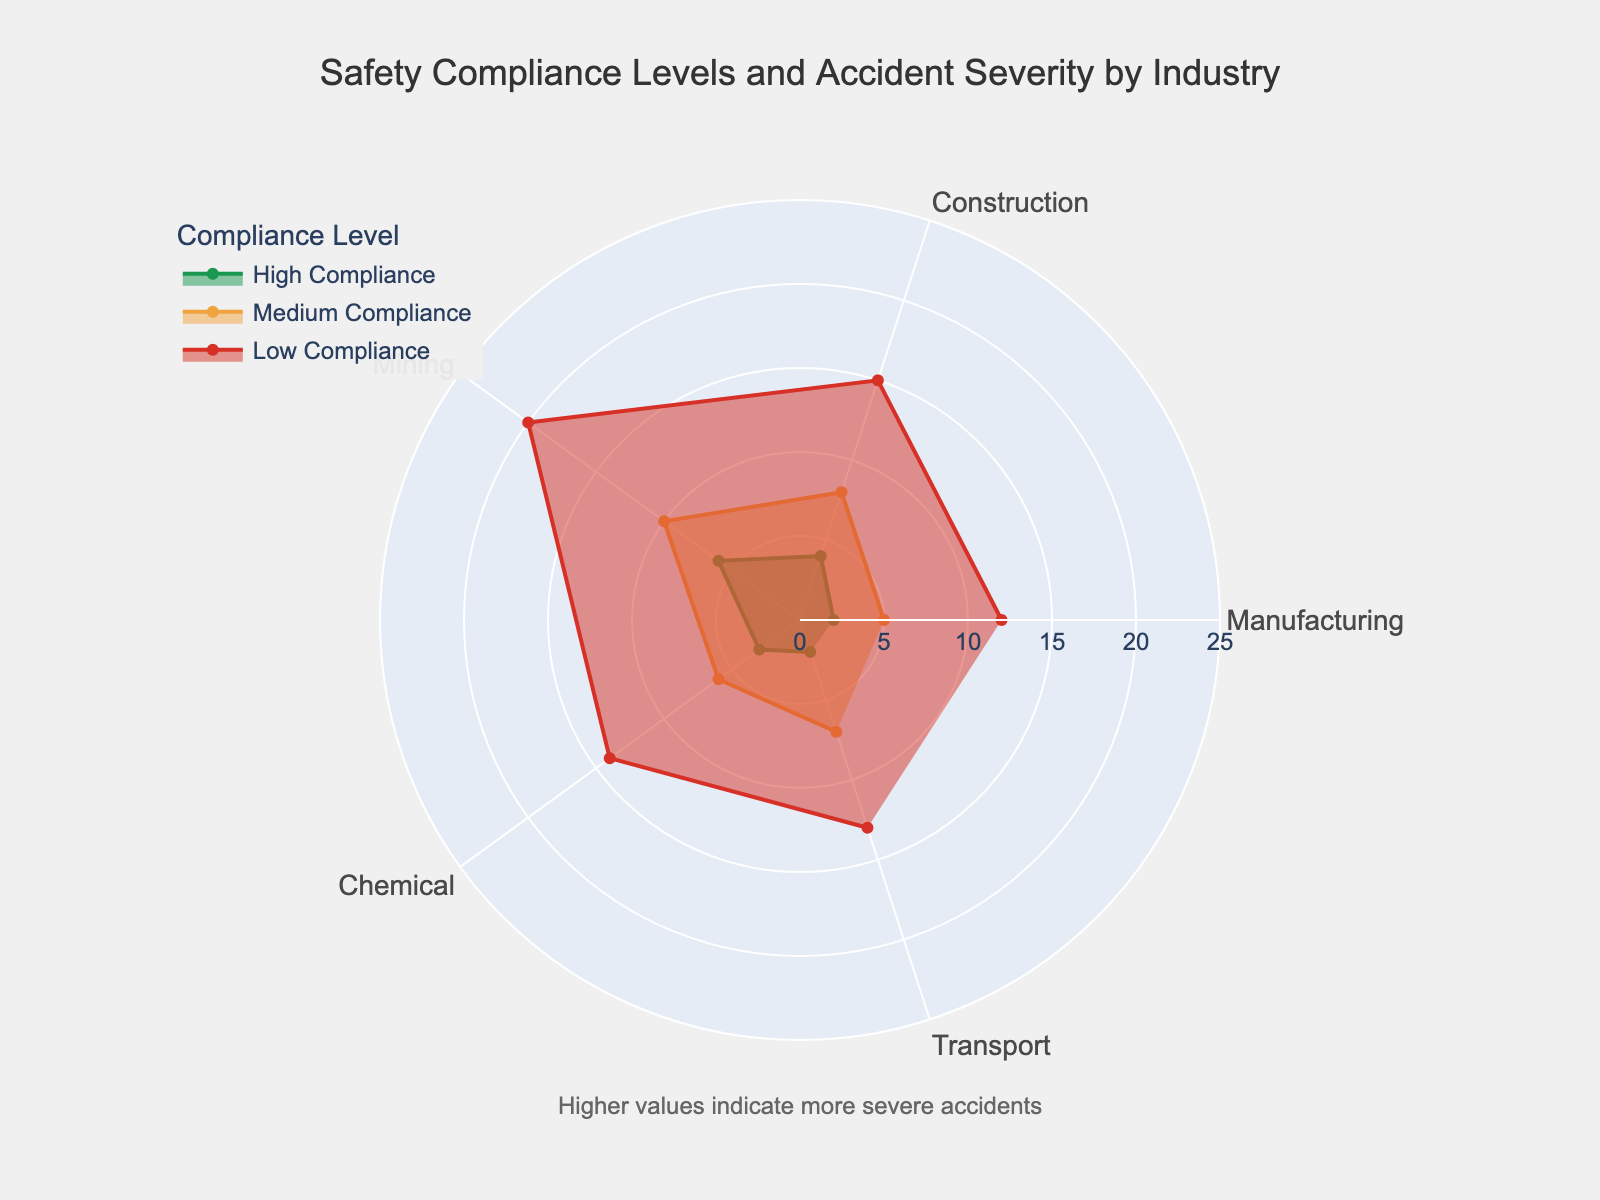What is the title of the figure? The title is usually displayed at the top of the figure. In this case, the title is "Safety Compliance Levels and Accident Severity by Industry."
Answer: Safety Compliance Levels and Accident Severity by Industry What industry has the highest accident severity level for High Compliance? To find this, look at the 'High Compliance' trace, find the highest value, and then identify the corresponding industry category. The maximum value is 6 for the Mining industry.
Answer: Mining Which compliance level shows the highest values of accident severity overall? Compare the values across the different compliance levels. The 'Low Compliance' category has higher values in all industries.
Answer: Low Compliance What is the accident severity in the Transport industry with Medium Compliance? Find the 'Medium Compliance' trace and look for the value associated with the Transport industry. The value is 7.
Answer: 7 How do the accident severity levels in the Construction industry compare between Medium and Low Compliance? Identify the values for the Construction industry in both Medium and Low Compliance. Medium Compliance is 8, and Low Compliance is 15.
Answer: Medium: 8, Low: 15 What is the sum of accident severity levels for the Manufacturing industry across all compliance levels? Add the accident severity levels for High, Medium, and Low Compliance in the Manufacturing industry: 2 + 5 + 12 = 19.
Answer: 19 Which industry has the least severe accidents with Medium Compliance? Look for the smallest value in the Medium Compliance category. The Manufacturing industry has the lowest value with 5.
Answer: Manufacturing Are there any industries where High Compliance results in more severe accidents than Medium Compliance? Compare the values for each industry between High and Medium Compliance. No, in all industries, High Compliance results in lower or equal severity than Medium Compliance.
Answer: No What is the average accident severity for the Mining industry across all compliance levels? Add the accident severity levels for High, Medium, and Low Compliance in the Mining industry and divide by 3: (6 + 10 + 20) / 3 = 12.
Answer: 12 How does the severity of accidents in the Chemical industry with Low Compliance compare to that in the Transport industry with Low Compliance? Compare the values for Low Compliance in both the Chemical and Transport industries. Chemical is 14, and Transport is 13.
Answer: Chemical: 14, Transport: 13 